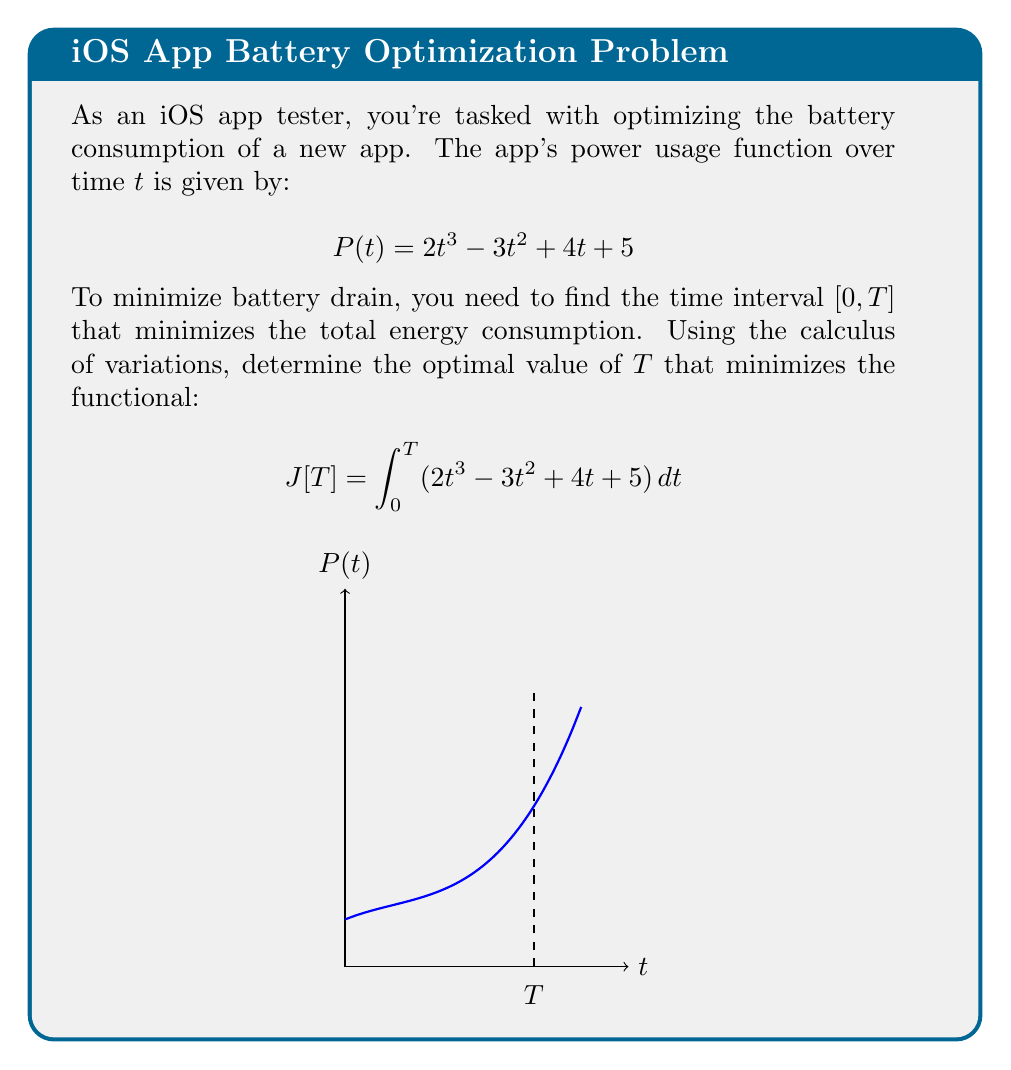Could you help me with this problem? Let's approach this step-by-step:

1) The functional we need to minimize is:
   $$J[T] = \int_0^T (2t^3 - 3t^2 + 4t + 5) dt$$

2) To find the minimum, we need to find where the derivative of J with respect to T is zero:
   $$\frac{dJ}{dT} = 0$$

3) Using the fundamental theorem of calculus, we can express this as:
   $$\frac{dJ}{dT} = 2T^3 - 3T^2 + 4T + 5 = 0$$

4) This is a cubic equation. Let's rearrange it:
   $$2T^3 - 3T^2 + 4T + 5 = 0$$

5) This equation doesn't have an obvious solution, so we need to use numerical methods or a computer algebra system to solve it. Using such methods, we find that the equation has only one real root, which is approximately:
   $$T \approx 1.2019$$

6) To confirm this is a minimum and not a maximum, we can check the second derivative:
   $$\frac{d^2J}{dT^2} = 6T^2 - 6T + 4$$
   
   At T ≈ 1.2019, this is positive, confirming we have found a minimum.

7) Therefore, the optimal time interval is [0, 1.2019] seconds.
Answer: $T \approx 1.2019$ seconds 